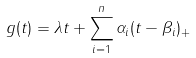Convert formula to latex. <formula><loc_0><loc_0><loc_500><loc_500>g ( t ) = \lambda t + \sum _ { i = 1 } ^ { n } \alpha _ { i } ( t - \beta _ { i } ) _ { + }</formula> 